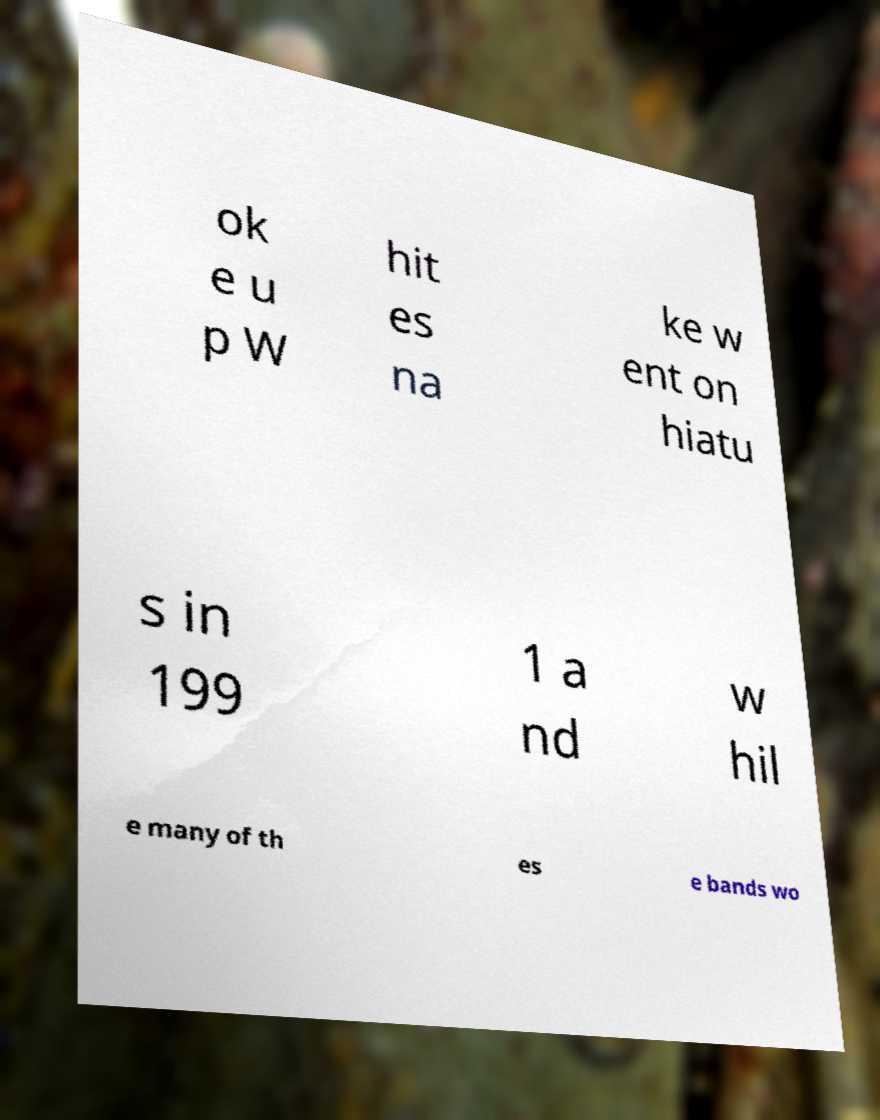What messages or text are displayed in this image? I need them in a readable, typed format. ok e u p W hit es na ke w ent on hiatu s in 199 1 a nd w hil e many of th es e bands wo 